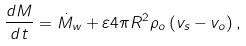<formula> <loc_0><loc_0><loc_500><loc_500>\frac { d M } { d t } = \dot { M } _ { w } + \varepsilon 4 \pi R ^ { 2 } \rho _ { o } \left ( v _ { s } - v _ { o } \right ) ,</formula> 